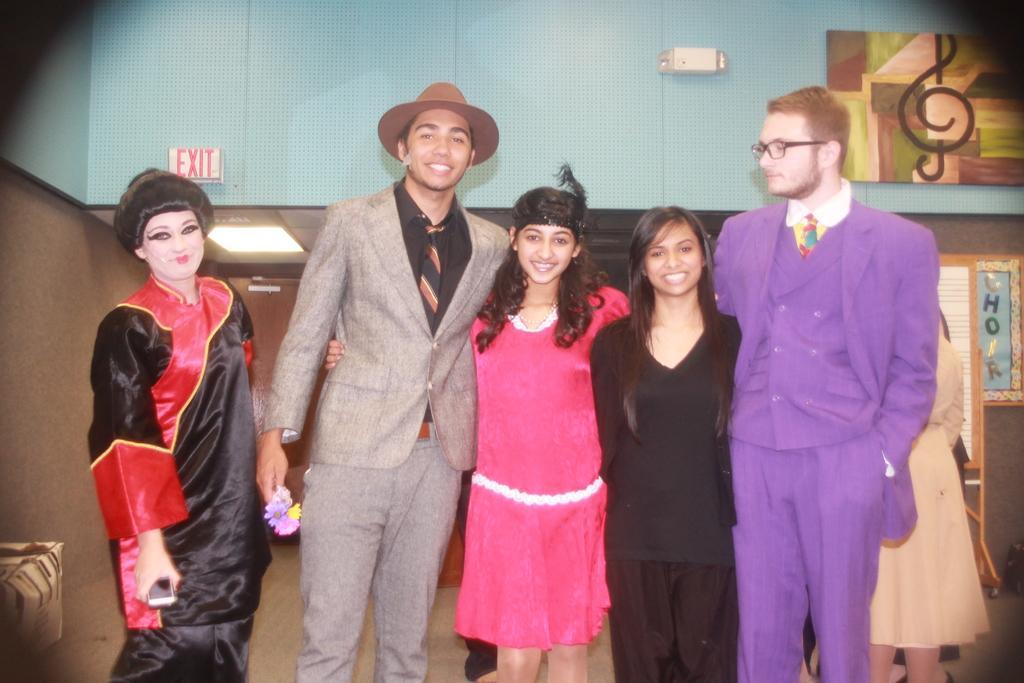Can you describe this image briefly? In this picture I can see few people standing and I can see a man wore cap on his head and I can see few people standing on the back and a board with some text and I can see painting on the wall and I can see a sign board with text on the wall 